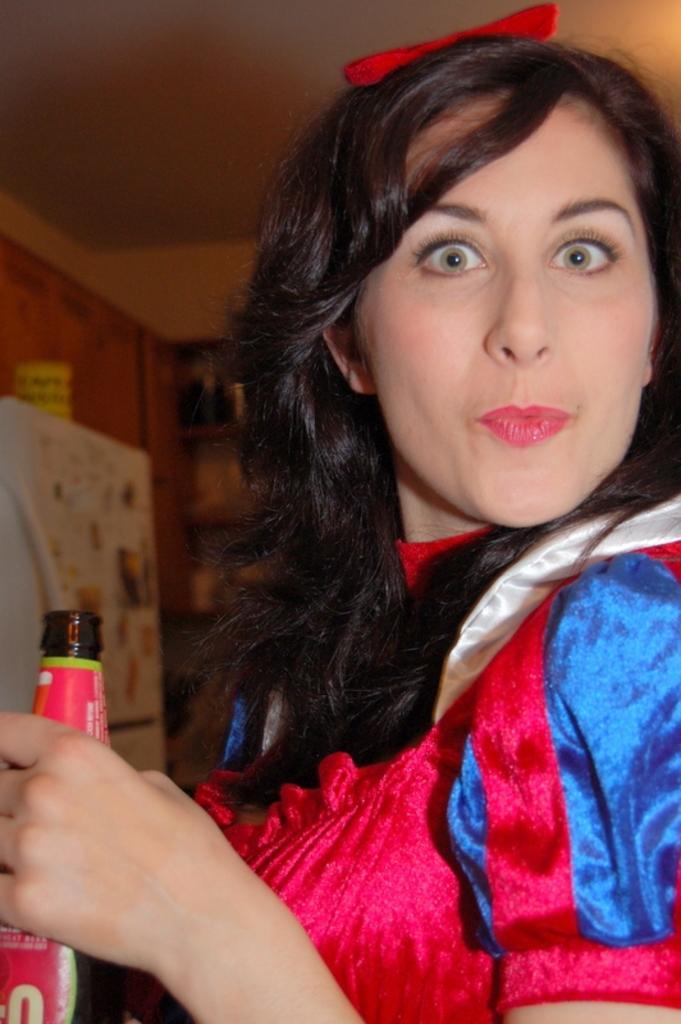In one or two sentences, can you explain what this image depicts? In this image there is a woman wearing red dress, red ribbon and holding a bottle. The bottle is labeled in red in color. In the background there are cupboards, fridge and wall. 